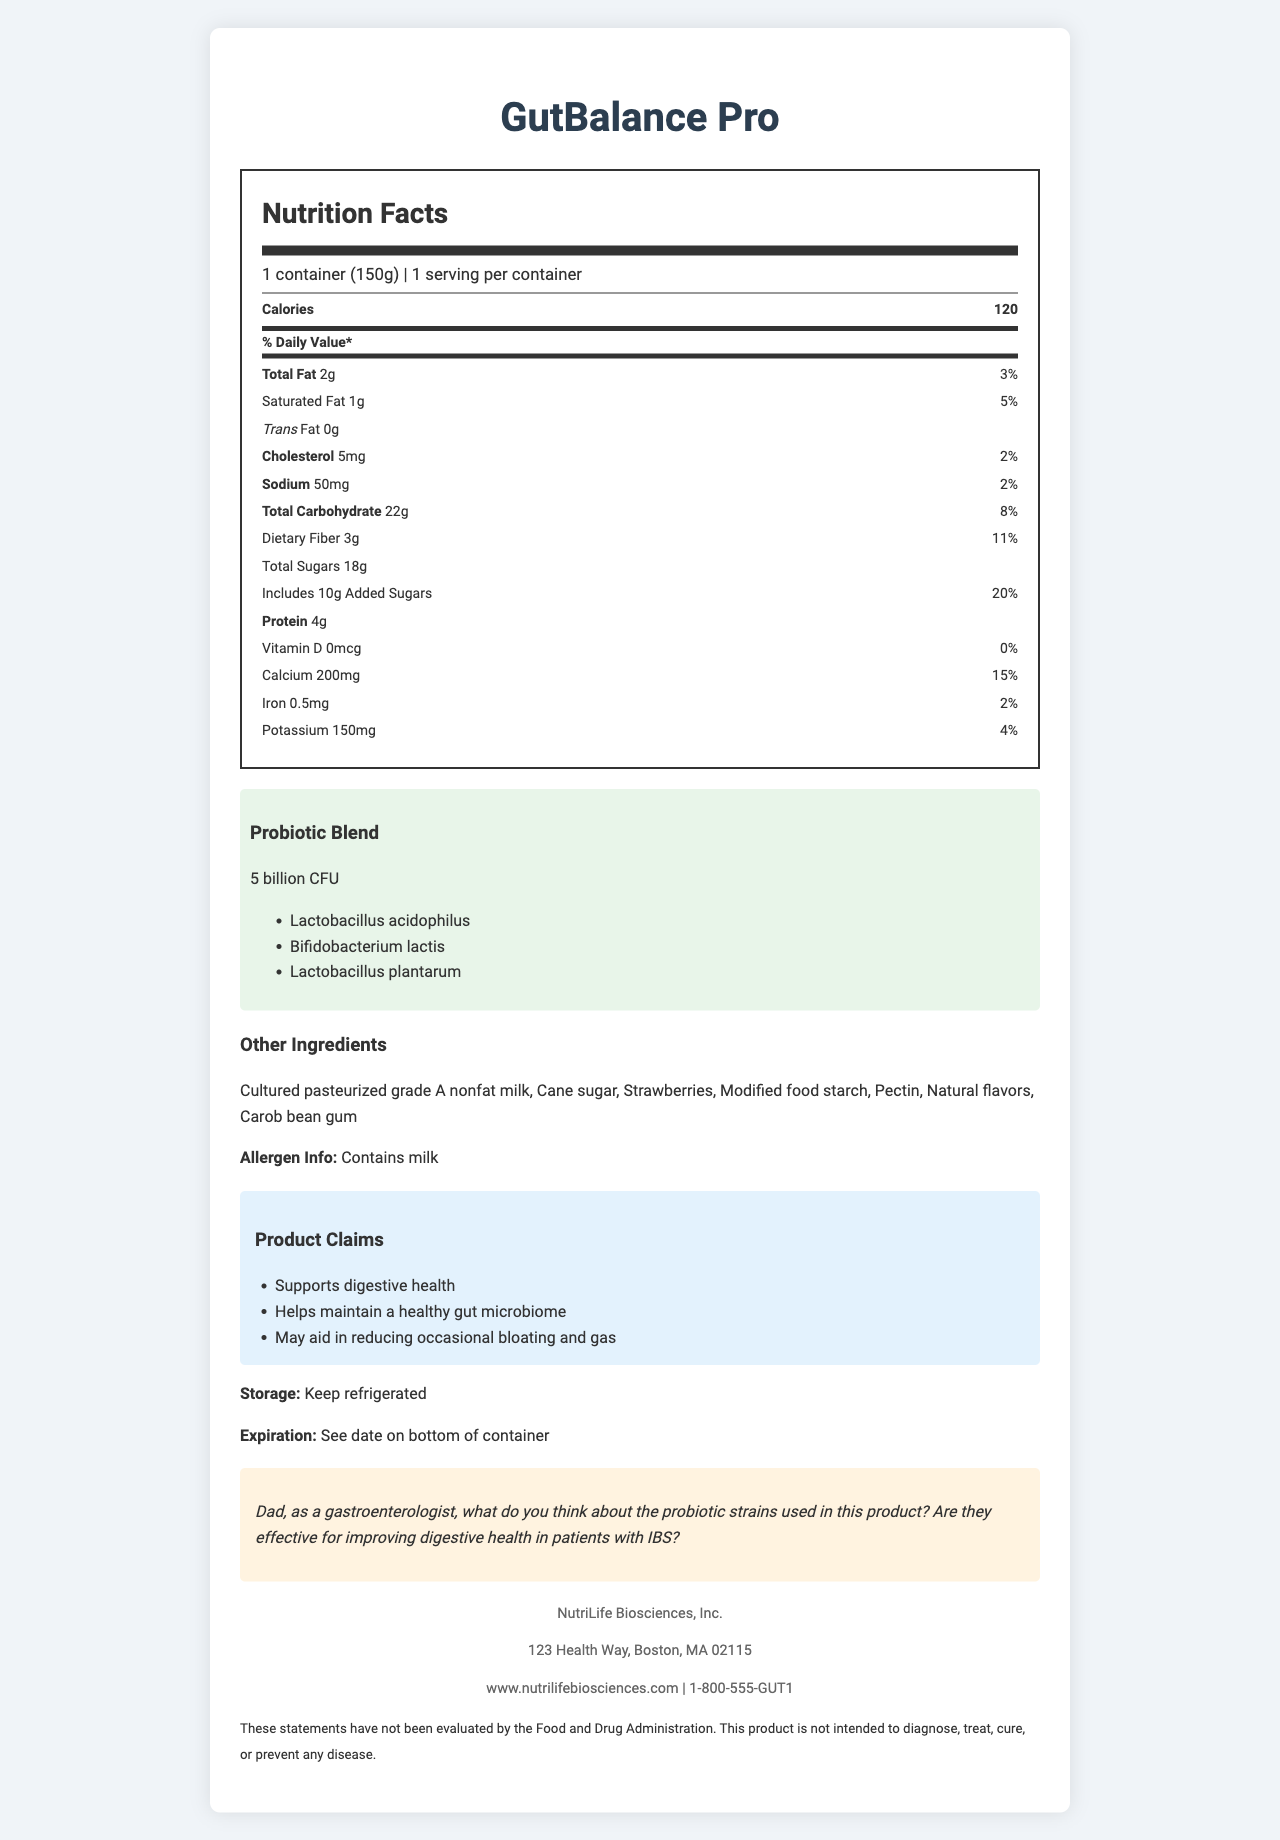what is the serving size of GutBalance Pro? The serving size is specified at the beginning of the nutrition label.
Answer: 1 container (150g) how many calories are there per serving? The calories per serving information is highlighted prominently in the nutrition label.
Answer: 120 What is the total carbohydrate content per serving? The total carbohydrate amount per serving is clearly listed under the carbohydrate section of the nutrition label.
Answer: 22g does this product contain any trans fat? Under the fat section, the label explicitly states that the trans fat content is 0g.
Answer: No List the ingredients included in the probiotic blend. The ingredients of the probiotic blend are listed in a specialized section of the document.
Answer: Lactobacillus acidophilus, Bifidobacterium lactis, Lactobacillus plantarum How much dietary fiber does one serving of GutBalance Pro provide? The dietary fiber content is listed under the carbohydrate section with a value of 3g.
Answer: 3g Does GutBalance Pro claim to support digestive health? This claim is explicitly mentioned in the product claims section.
Answer: Yes What is the percentage of the daily value for calcium provided per serving? The daily value percentage for calcium is listed as 15% under the vitamin and mineral section.
Answer: 15% How many total sugars are in one serving? A. 10g B. 15g C. 18g D. 22g The nutrition label states that the total sugars content per serving is 18g.
Answer: C. 18g How much added sugars does this product contain? A. 5g B. 10g C. 15g D. 20g The label specifies that the product includes 10g of added sugars.
Answer: B. 10g Does GutBalance Pro contain milk? The allergen information clearly states that the product contains milk.
Answer: Yes Summarize the claims made by GutBalance Pro. The claims section of the document lists these three specific benefits that the product aims to offer.
Answer: GutBalance Pro claims to support digestive health, help maintain a healthy gut microbiome, and may aid in reducing occasional bloating and gas. Is there any vitamin D in GutBalance Pro? The nutrition label shows that the vitamin D content is 0mcg, which is 0% of the daily value.
Answer: No Can we determine if this product is suitable for people with diabetes based on the document? The document does not provide specific information about suitability for people with diabetes apart from the sugar content.
Answer: Cannot be determined What should you do to store this product safely? The storage instructions clearly state that the product should be kept refrigerated.
Answer: Keep refrigerated Would you find information on the expiration date directly on the container? The document mentions that the expiration date is indicated on the bottom of the container.
Answer: Yes Who is the manufacturer of GutBalance Pro? The manufacturer information section at the bottom of the document provides the name NutriLife Biosciences, Inc.
Answer: NutriLife Biosciences, Inc. 